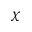<formula> <loc_0><loc_0><loc_500><loc_500>\chi</formula> 